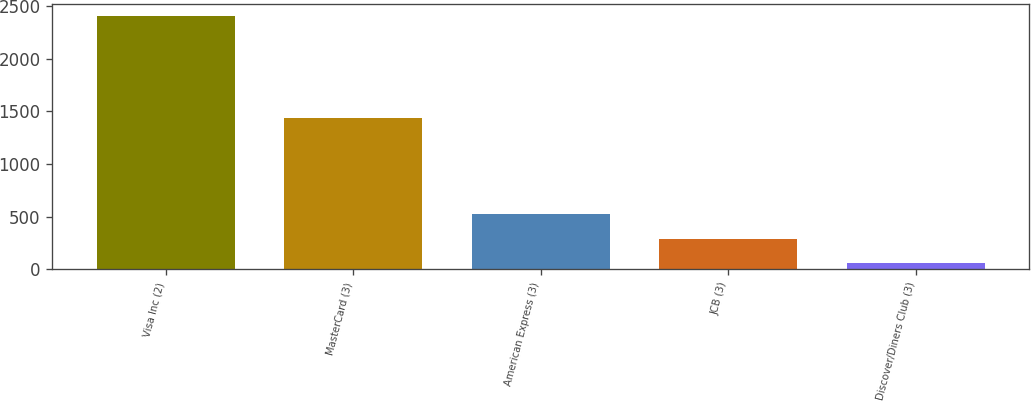Convert chart. <chart><loc_0><loc_0><loc_500><loc_500><bar_chart><fcel>Visa Inc (2)<fcel>MasterCard (3)<fcel>American Express (3)<fcel>JCB (3)<fcel>Discover/Diners Club (3)<nl><fcel>2402<fcel>1437<fcel>526<fcel>291.5<fcel>57<nl></chart> 